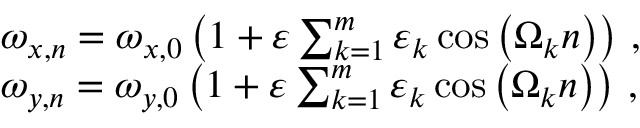Convert formula to latex. <formula><loc_0><loc_0><loc_500><loc_500>\begin{array} { r l } & { \omega _ { x , n } = \omega _ { x , 0 } \left ( 1 + \varepsilon \sum _ { k = 1 } ^ { m } \varepsilon _ { k } \cos \left ( \Omega _ { k } n \right ) \right ) \, , } \\ & { \omega _ { y , n } = \omega _ { y , 0 } \left ( 1 + \varepsilon \sum _ { k = 1 } ^ { m } \varepsilon _ { k } \cos \left ( \Omega _ { k } n \right ) \right ) \, , } \end{array}</formula> 